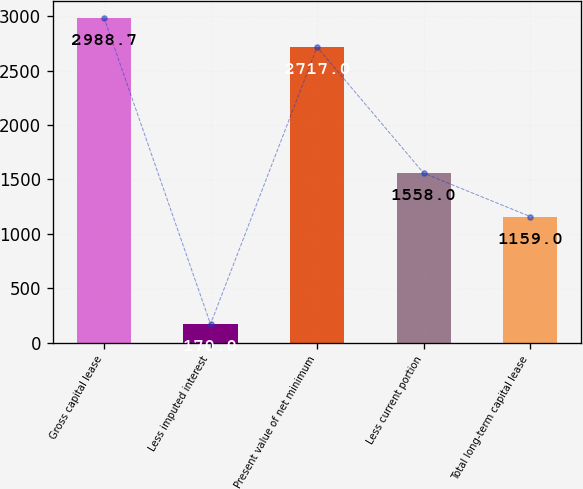<chart> <loc_0><loc_0><loc_500><loc_500><bar_chart><fcel>Gross capital lease<fcel>Less imputed interest<fcel>Present value of net minimum<fcel>Less current portion<fcel>Total long-term capital lease<nl><fcel>2988.7<fcel>170<fcel>2717<fcel>1558<fcel>1159<nl></chart> 